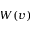<formula> <loc_0><loc_0><loc_500><loc_500>W ( v )</formula> 